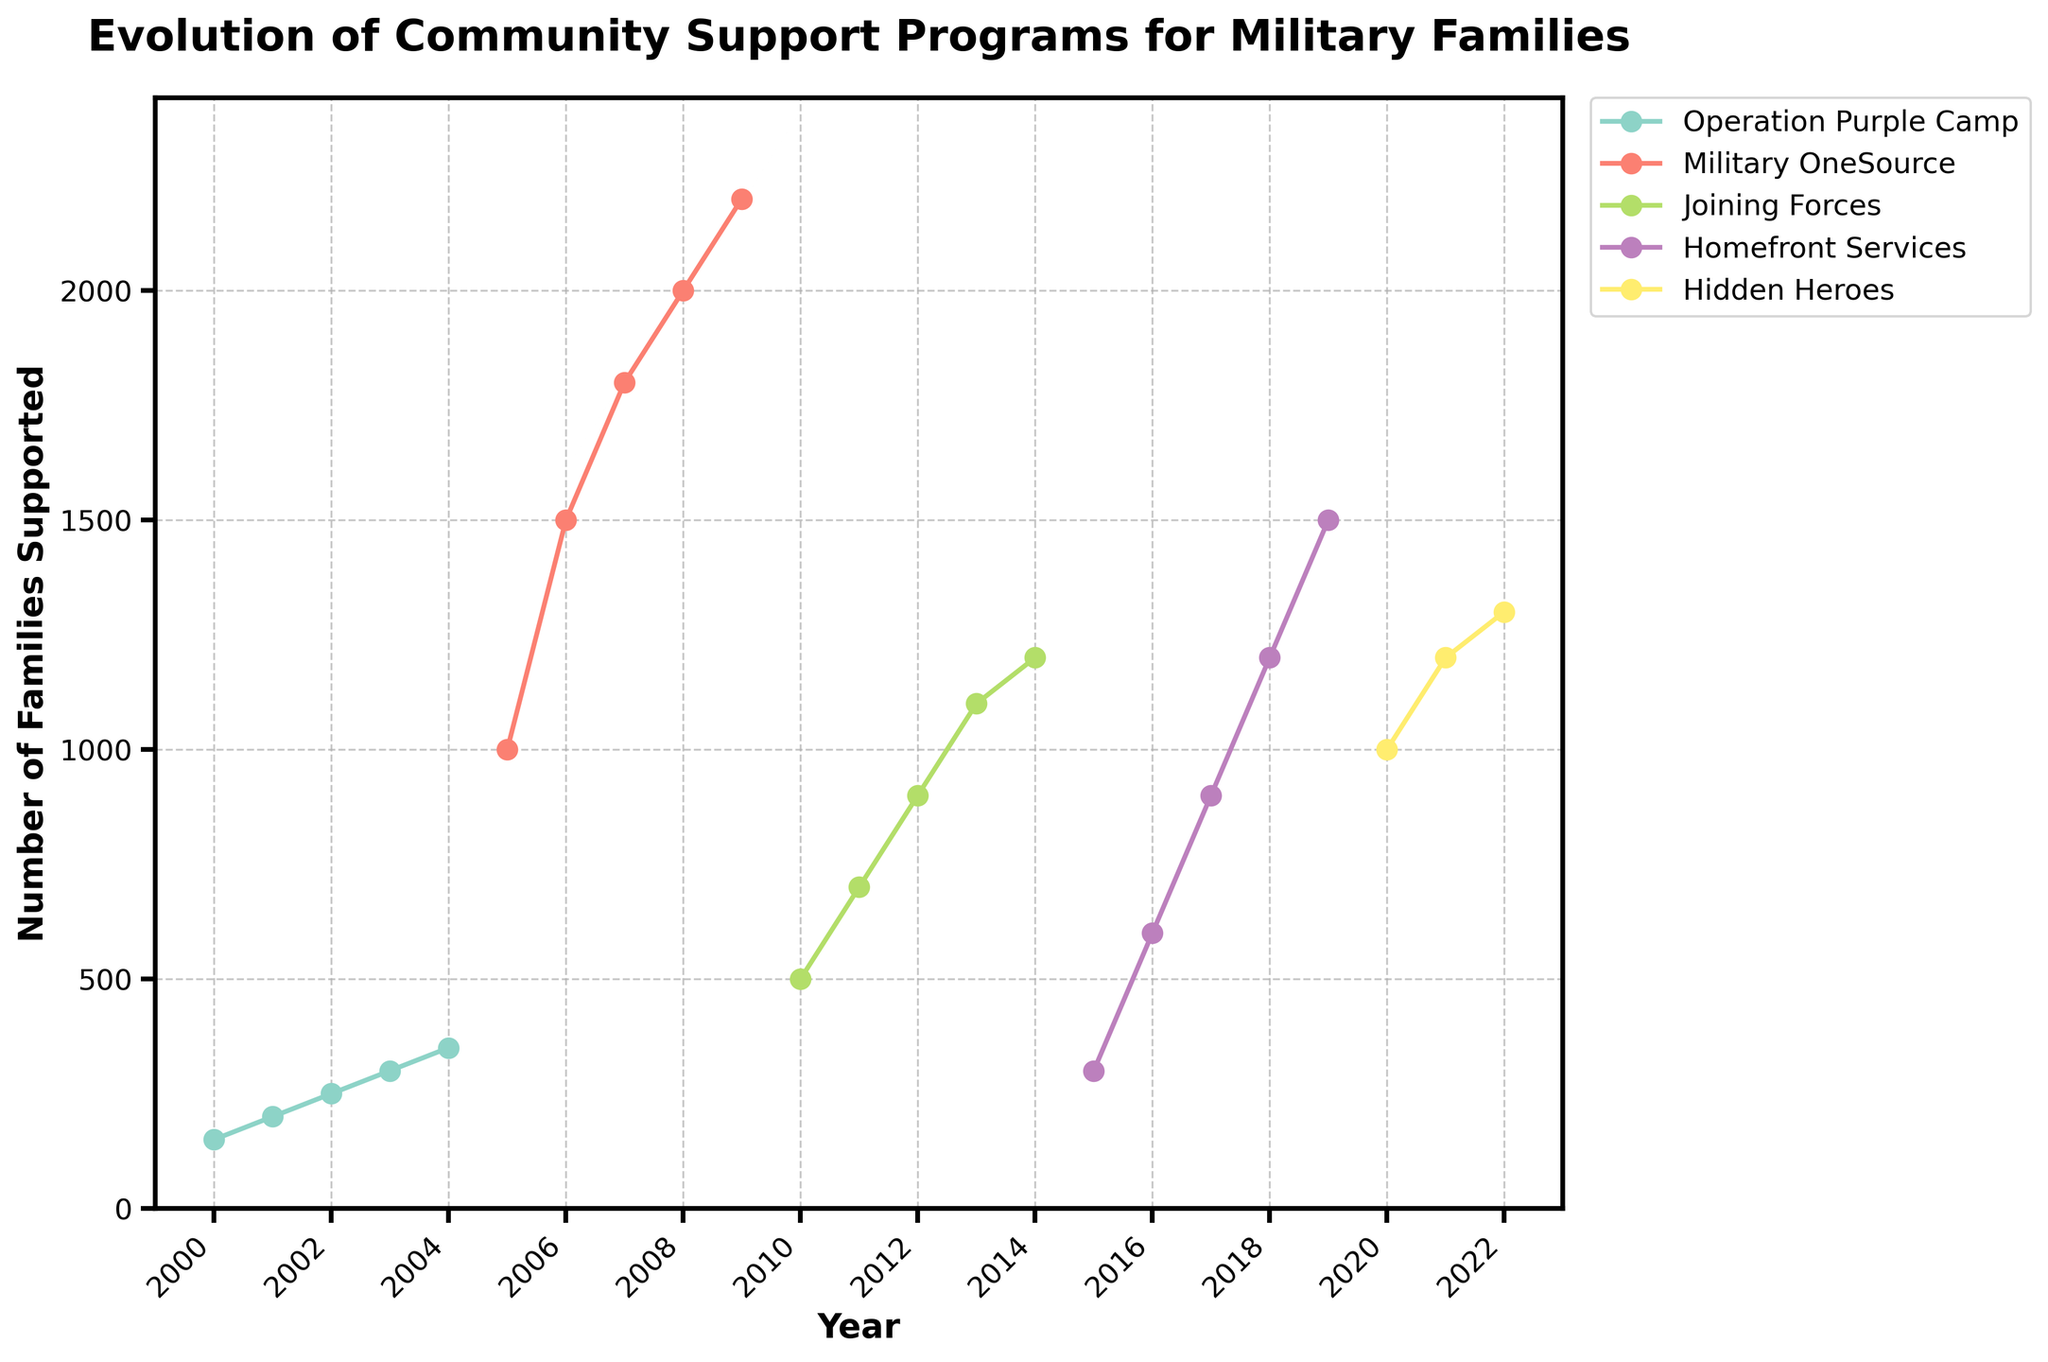What is the title of the figure? The title is prominently displayed at the top of the figure as part of the visual design. By looking at the top center of the figure, you can see the title text which conveys the main theme of the chart.
Answer: Evolution of Community Support Programs for Military Families How many unique programs are displayed in the figure? Each unique program is represented by a different colored line on the plot. By counting the individual lines and checking the legend, you can determine the number of unique programs.
Answer: 5 Which program supported the highest number of families in any given year? By examining the peaks of each line on the chart, you can identify which program reached the highest point on the y-axis, which quantifies the number of families supported.
Answer: Military OneSource In what year did the "Joining Forces" program begin, according to the figure? To find the initial year of the "Joining Forces" program, locate the first data point of the colored line linked to the "Joining Forces" label, referencing the x-axis for the corresponding year.
Answer: 2010 What was the trend in the number of families supported by "Homefront Services" from 2015 to 2019? Look at the slope of the line representing "Homefront Services" in the figure over the years 2015 to 2019. An upward movement will indicate an increasing trend.
Answer: Increasing How does the support trend for "Hidden Heroes" compare to "Operation Purple Camp" over their respective timeframes? Compare the slopes of both lines. The steeper the slope, the faster the rate of increase or decrease in support. Also, consider the overall direction (upward/downward) of the lines.
Answer: "Hidden Heroes" shows a consistent increase, while "Operation Purple Camp" shows an initial increase and then stabilizes Between which years did "Military OneSource" show the most significant growth in the number of families supported? Look for the largest vertical increase between consecutive data points on the "Military OneSource" line.
Answer: 2005 to 2006 What is the general trend observed for all programs combined over the years? By observing the collective direction and steepness of all lines over the x-axis, one can derive whether the general trend is upward, downward, or stable.
Answer: Upward How many families were supported by "Operation Purple Camp" in 2004, and how does it compare to "Joining Forces" in 2014? Refer to the points on the "Operation Purple Camp" line for the year 2004 and the "Joining Forces" line for 2014. Compare the y-axis values of these points.
Answer: 350 families in 2004 vs. 1200 families in 2014 